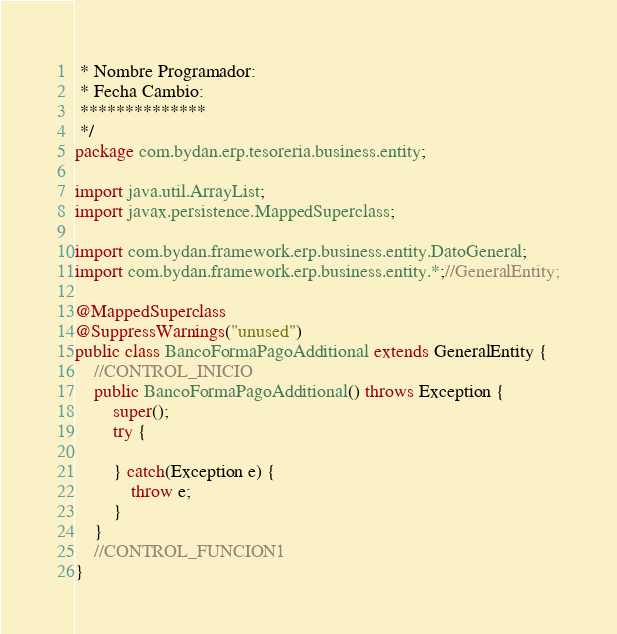Convert code to text. <code><loc_0><loc_0><loc_500><loc_500><_Java_> * Nombre Programador:
 * Fecha Cambio:
 **************
 */
package com.bydan.erp.tesoreria.business.entity;

import java.util.ArrayList;
import javax.persistence.MappedSuperclass;

import com.bydan.framework.erp.business.entity.DatoGeneral;
import com.bydan.framework.erp.business.entity.*;//GeneralEntity;

@MappedSuperclass
@SuppressWarnings("unused")
public class BancoFormaPagoAdditional extends GeneralEntity {
	//CONTROL_INICIO	
	public BancoFormaPagoAdditional() throws Exception {
		super();	
		try {
					
		} catch(Exception e) {
			throw e;
		}
	} 
	//CONTROL_FUNCION1
}</code> 